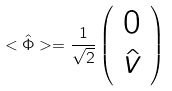Convert formula to latex. <formula><loc_0><loc_0><loc_500><loc_500>< \hat { \Phi } > = \frac { 1 } { \sqrt { 2 } } \left ( \begin{array} { c r } 0 \\ \hat { v } \end{array} \right )</formula> 